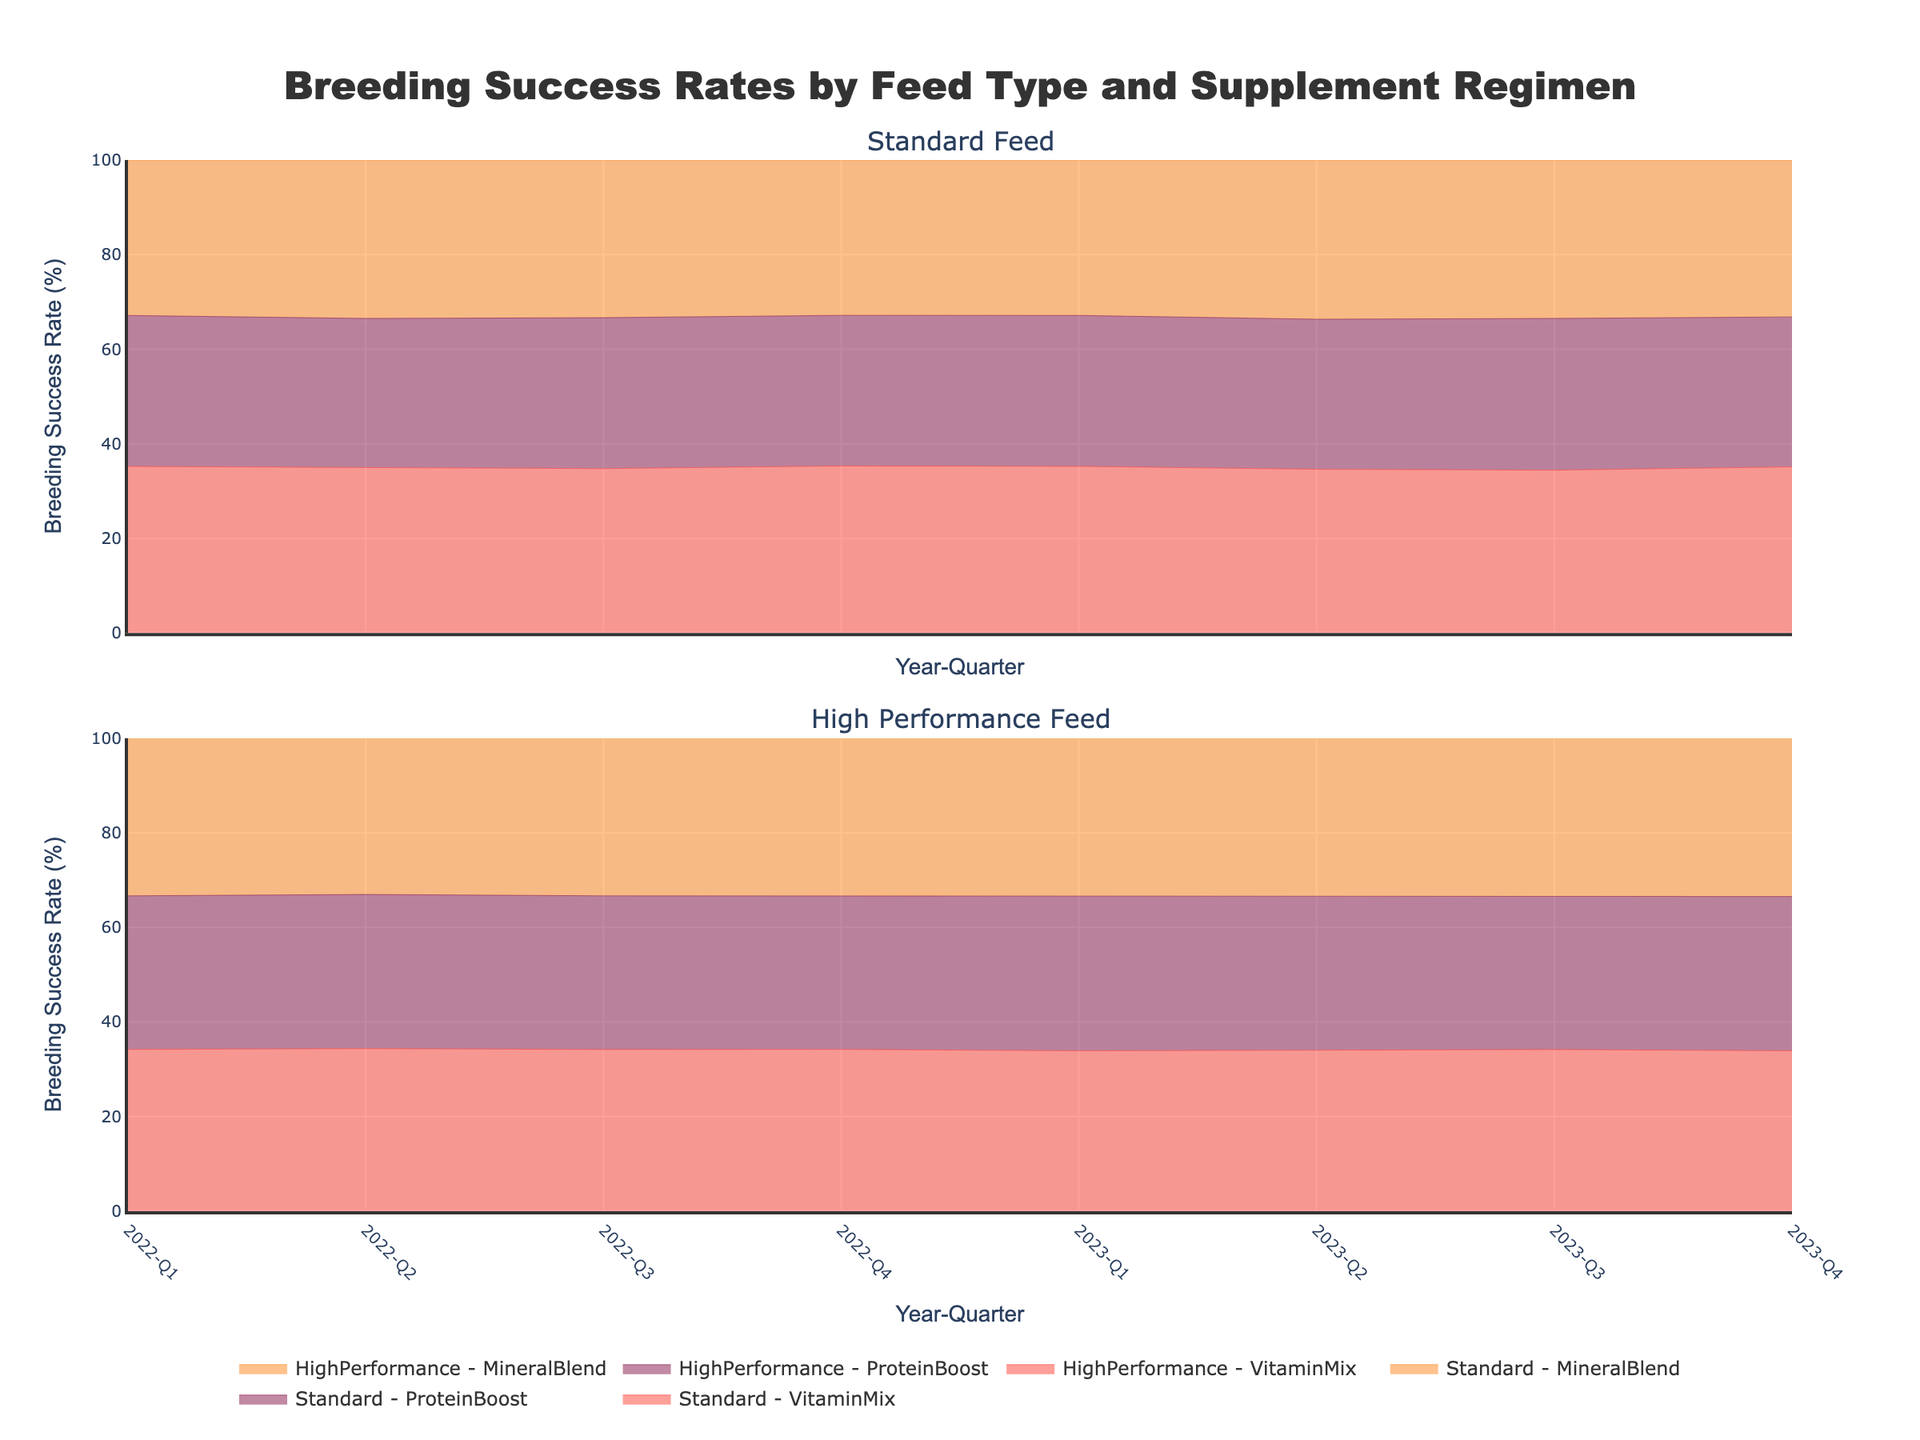What is the title of the figure? The figure's title is often prominently displayed at the top. In this case, the title describes the main theme of the data represented in the figure.
Answer: Breeding Success Rates by Feed Type and Supplement Regimen How many quarters are represented in the chart? By looking at the x-axis, which generally represents the temporal dimension, you can count the distinct quarterly labels displayed.
Answer: Eight quarters What are the two main categories of feed types displayed in the subplots? The titles of the two individual subplots will indicate the two main categories of feed types.
Answer: Standard Feed and High Performance Feed Which feed type and supplement regimen combination had the highest breeding success rate in Q3 2023? To determine this, look at the data lines in Q3 2023 and identify the combination with the highest peak on the y-axis for breeding success rate in the subplot labeled “High Performance Feed”.
Answer: High Performance Feed - VitaminMix How does the breeding success rate for the 'High Performance' feed type with the 'ProteinBoost' supplement regimen change from Q1 2022 to Q4 2023? Trace the 'ProteinBoost' line in the subplot for 'High Performance Feed' from Q1 2022 to Q4 2023 and observe the trend. Compare the values at the endpoints to understand the change.
Answer: It increases from 0.76 to 0.77 What is the average breeding success rate for the 'Standard Feed' with the 'VitaminMix' supplement across all quarters? Add the breeding success rates for the 'Standard Feed' with 'VitaminMix' across all quarters and divide by the number of quarters to find the average.
Answer: (0.75+0.72+0.73+0.71+0.74+0.72+0.73+0.72)/8 = 0.7275 Compare the breeding success rates for 'Standard Feed' with 'ProteinBoost' and 'MineralBlend' in Q2 2022. Which is higher? Look at the specific lines for 'ProteinBoost' and 'MineralBlend' under 'Standard Feed' in Q2 2022 and compare their y-values to see which is higher.
Answer: MineralBlend Which quarter had the lowest breeding success rate for Standard Feed with any supplement regimen? Identify the point with the lowest y-value under the 'Standard Feed' subplot. Note the corresponding quarter on the x-axis.
Answer: Q4 2022 In which year does the 'High Performance Feed' with 'VitaminMix' consistently show high breeding success rates? Observe the lines for 'High Performance Feed' with 'VitaminMix' throughout both years and determine which year has higher and more consistent success rates.
Answer: 2023 What is the trend in breeding success rate for 'High Performance Feed' with 'MineralBlend' from Q1 2022 to Q4 2023? Follow the line for 'High Performance Feed' with 'MineralBlend' and observe its trajectory over the quarters from Q1 2022 to Q4 2023 to determine the nature of the trend.
Answer: It generally increases 